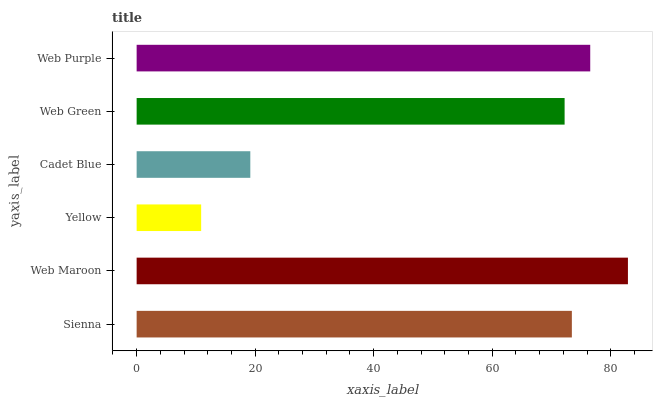Is Yellow the minimum?
Answer yes or no. Yes. Is Web Maroon the maximum?
Answer yes or no. Yes. Is Web Maroon the minimum?
Answer yes or no. No. Is Yellow the maximum?
Answer yes or no. No. Is Web Maroon greater than Yellow?
Answer yes or no. Yes. Is Yellow less than Web Maroon?
Answer yes or no. Yes. Is Yellow greater than Web Maroon?
Answer yes or no. No. Is Web Maroon less than Yellow?
Answer yes or no. No. Is Sienna the high median?
Answer yes or no. Yes. Is Web Green the low median?
Answer yes or no. Yes. Is Web Purple the high median?
Answer yes or no. No. Is Cadet Blue the low median?
Answer yes or no. No. 